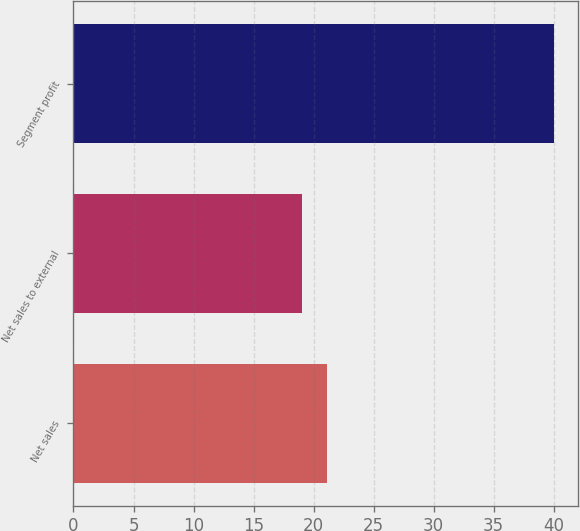<chart> <loc_0><loc_0><loc_500><loc_500><bar_chart><fcel>Net sales<fcel>Net sales to external<fcel>Segment profit<nl><fcel>21.1<fcel>19<fcel>40<nl></chart> 